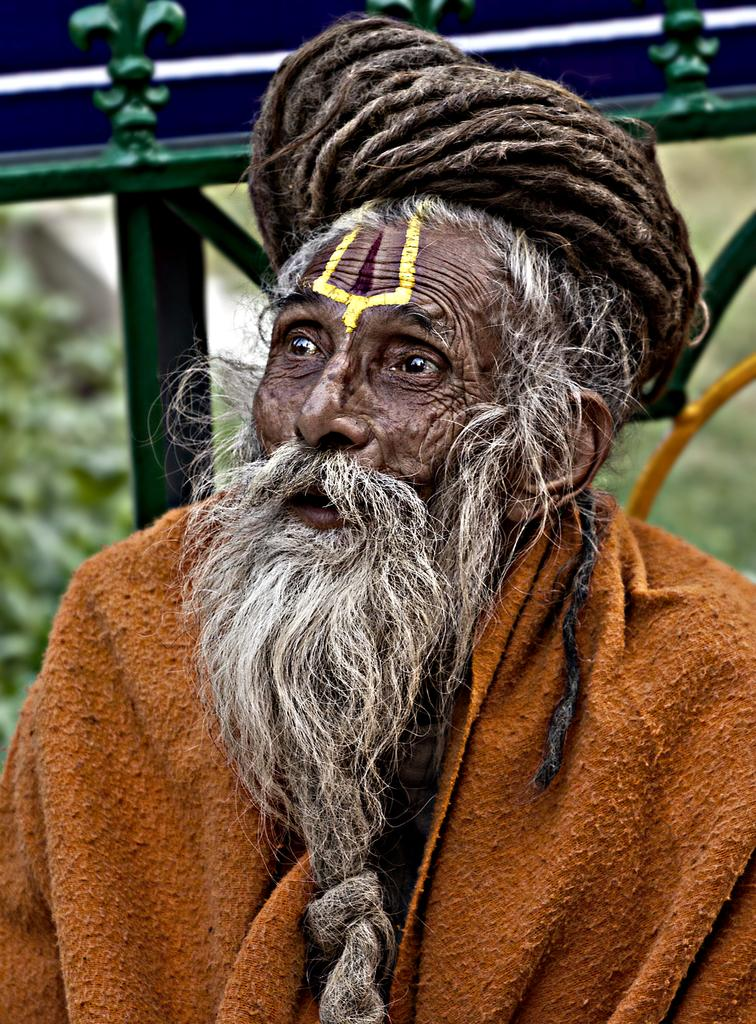Who is present in the image? There is a man in the image. What object can be seen in the image besides the man? There is a cloth in the image. What is the color of the cloth? The cloth is light brown in color. Can you describe the background of the image? The background of the image is blurred. What type of fear is the man expressing in the image? There is no indication of fear in the image; the man's expression or body language does not suggest any particular emotion. 